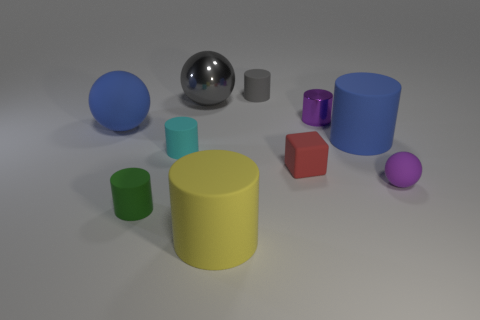Subtract all blue spheres. How many spheres are left? 2 Subtract 3 balls. How many balls are left? 0 Subtract all blue cylinders. How many cylinders are left? 5 Add 8 green matte cylinders. How many green matte cylinders exist? 9 Subtract 0 cyan cubes. How many objects are left? 10 Subtract all blocks. How many objects are left? 9 Subtract all cyan cylinders. Subtract all purple blocks. How many cylinders are left? 5 Subtract all gray spheres. How many purple cylinders are left? 1 Subtract all large blue cylinders. Subtract all large green matte cubes. How many objects are left? 9 Add 4 big gray spheres. How many big gray spheres are left? 5 